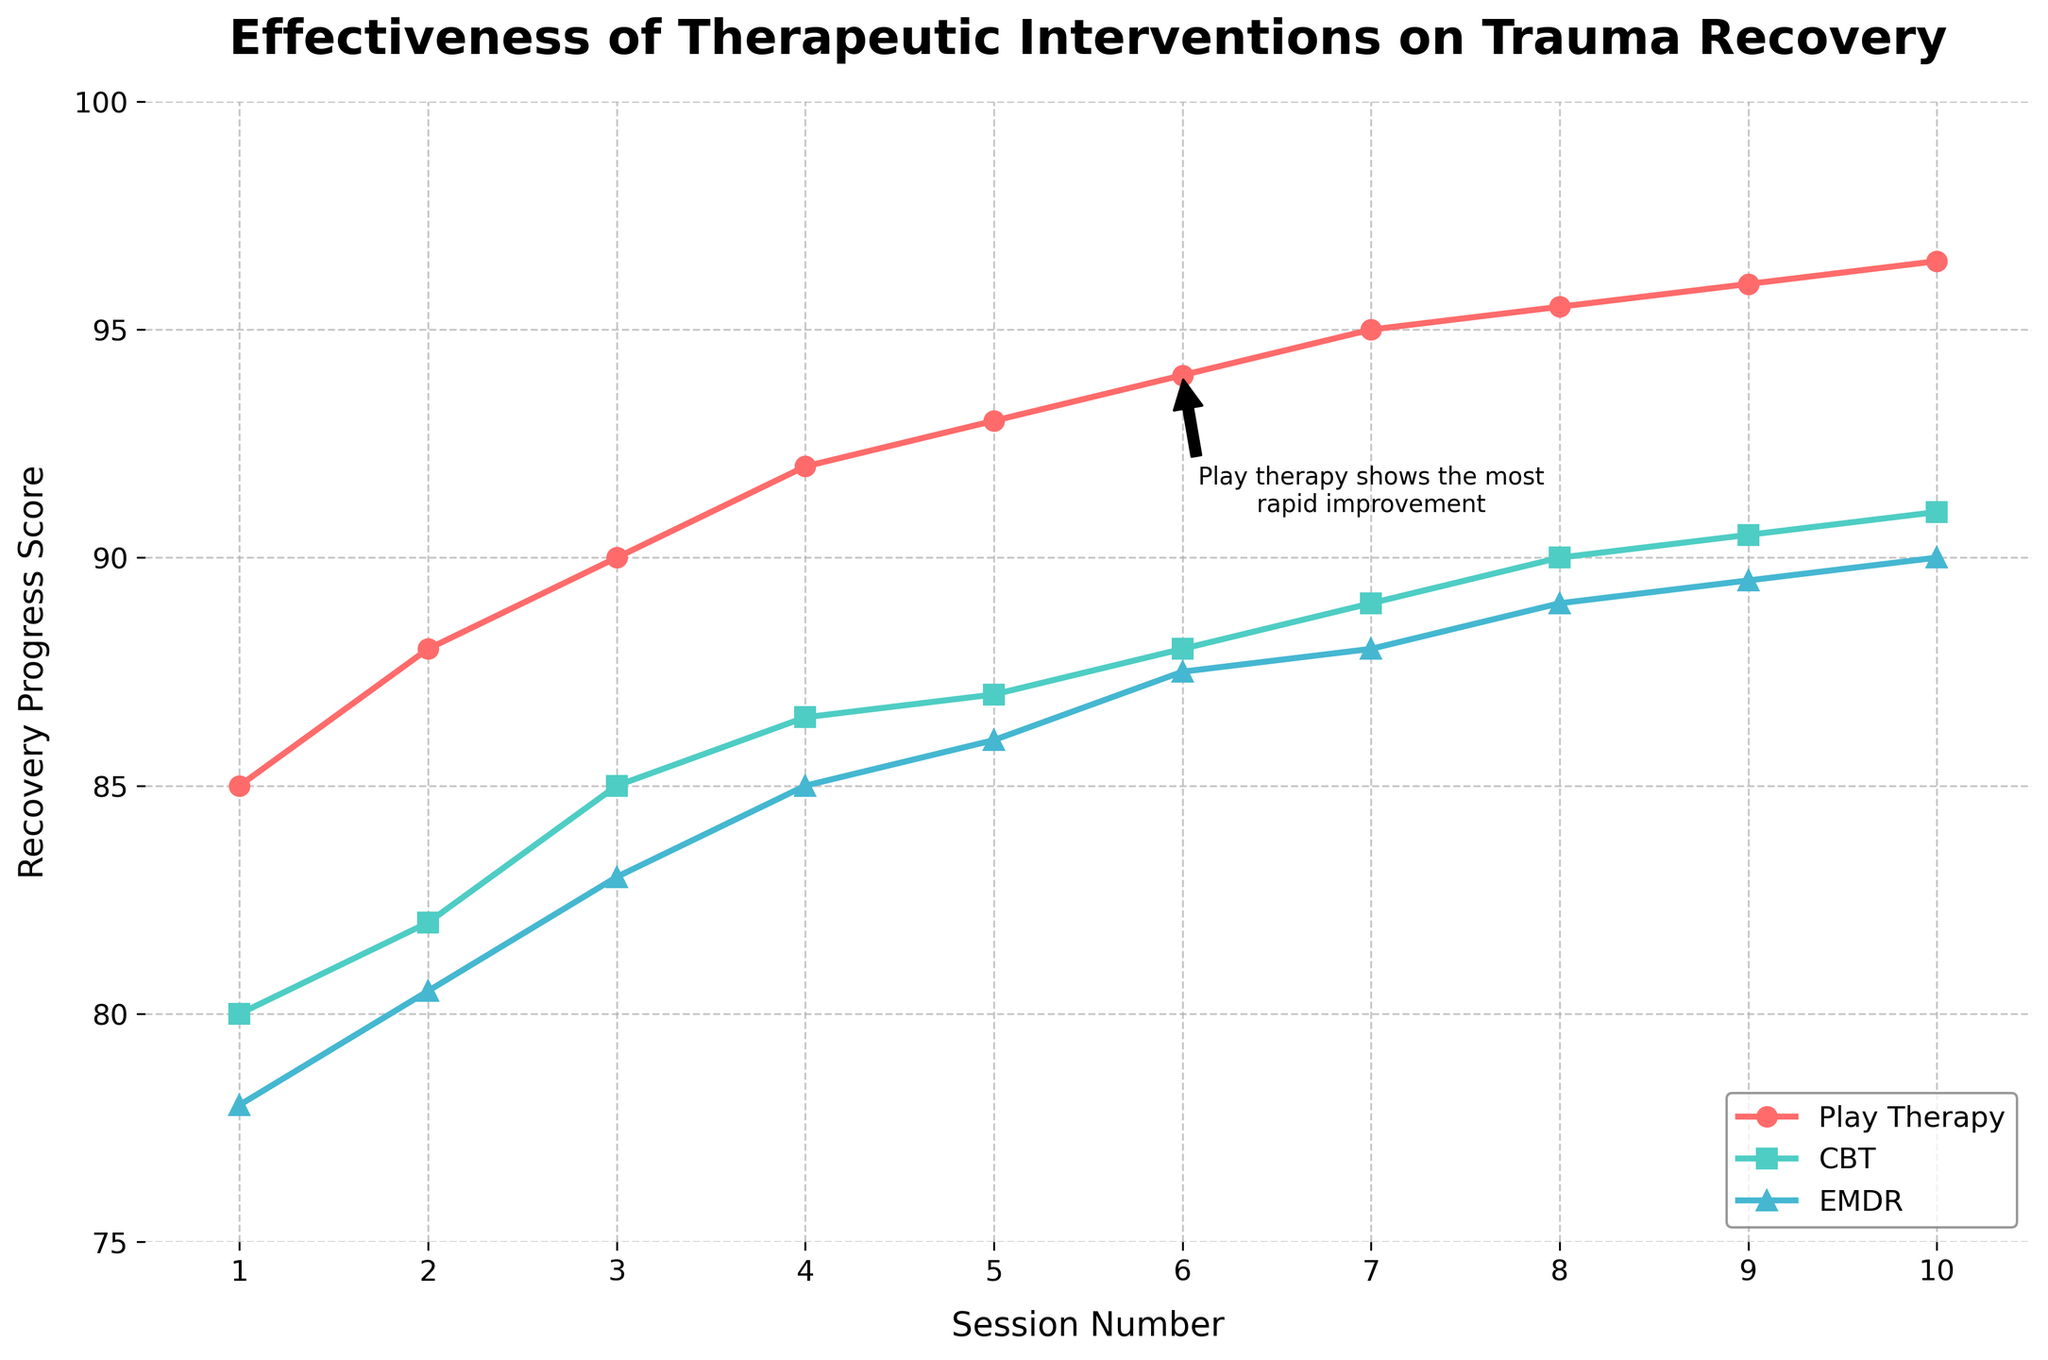What is the title of the plot? *The title is visible at the top of the plot. It reads:* 'Effectiveness of Therapeutic Interventions on Trauma Recovery'
Answer: 'Effectiveness of Therapeutic Interventions on Trauma Recovery' What do the x-axis and y-axis represent in the plot? *The x-axis labels 'Session Number', and the y-axis labels 'Recovery Progress Score'.*
Answer: 'Session Number' (x-axis) and 'Recovery Progress Score' (y-axis) Which therapy group shows the highest recovery progress score after the first session? *Refer to the plot where Session 1 is marked, compare the values of the three therapy groups. Play Therapy Group has the highest initial score at 85.0.*
Answer: Play Therapy Group How many sessions are displayed in the plot? *Count the number of data points along the x-axis. The plot ranges from Session 1 to Session 10.*
Answer: 10 Which therapy group experiences the most rapid improvement by Session 6? *Look at the annotations and the trend lines. The annotation indicates and visually shows that Play Therapy Group experiences the most rapid improvement, reaching almost 94 by Session 6.*
Answer: Play Therapy Group What is the difference in recovery scores between Play Therapy Group and EMDR Group in Session 4? *Identify the values of Play Therapy Group (92.0) and EMDR Group (85.0) at Session 4. The difference is 92.0 - 85.0.*
Answer: 7.0 Between which sessions does Cognitive Behavioral Therapy Group show the greatest increase in recovery score? *Check the change in scores for the Cognitive Behavioral Therapy Group across each session. The largest increase is between Session 1 (80.0) and Session 3 (85.0), which is an increase of 5.0.*
Answer: Between Sessions 1 and 3 What is the average recovery progress score of the Play Therapy Group over all sessions? *Sum the recovery scores of the Play Therapy Group: 85.0 + 88.0 + 90.0 + 92.0 + 93.0 + 94.0 + 95.0 + 95.5 + 96.0 + 96.5 = 925. Then divide by the number of sessions (10): 925 / 10.*
Answer: 92.5 Which therapy group consistently shows the lowest recovery progress score throughout the sessions? *By observing the graph's trend lines, the EMDR Group generally has the lowest scores compared to the Play Therapy Group and Cognitive Behavioral Therapy Group.*
Answer: EMDR Group 